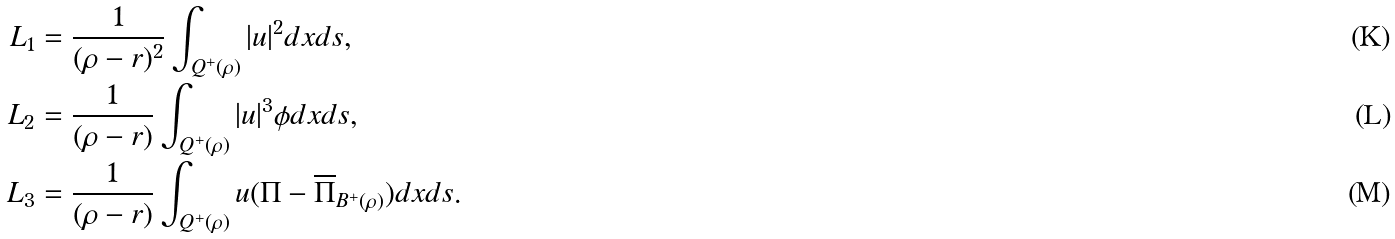Convert formula to latex. <formula><loc_0><loc_0><loc_500><loc_500>L _ { 1 } & = \frac { 1 } { ( \rho - r ) ^ { 2 } } \int _ { Q ^ { + } ( \rho ) } | u | ^ { 2 } d x d s , \\ L _ { 2 } & = \frac { 1 } { ( \rho - r ) } \int _ { Q ^ { + } ( \rho ) } | u | ^ { 3 } \phi d x d s , \\ L _ { 3 } & = \frac { 1 } { ( \rho - r ) } \int _ { Q ^ { + } ( \rho ) } u ( \Pi - \overline { \Pi } _ { B ^ { + } ( \rho ) } ) d x d s .</formula> 